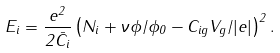Convert formula to latex. <formula><loc_0><loc_0><loc_500><loc_500>E _ { i } = \frac { e ^ { 2 } } { 2 \bar { C } _ { i } } \left ( N _ { i } + \nu \phi / \phi _ { 0 } - C _ { i g } V _ { g } / | e | \right ) ^ { 2 } .</formula> 